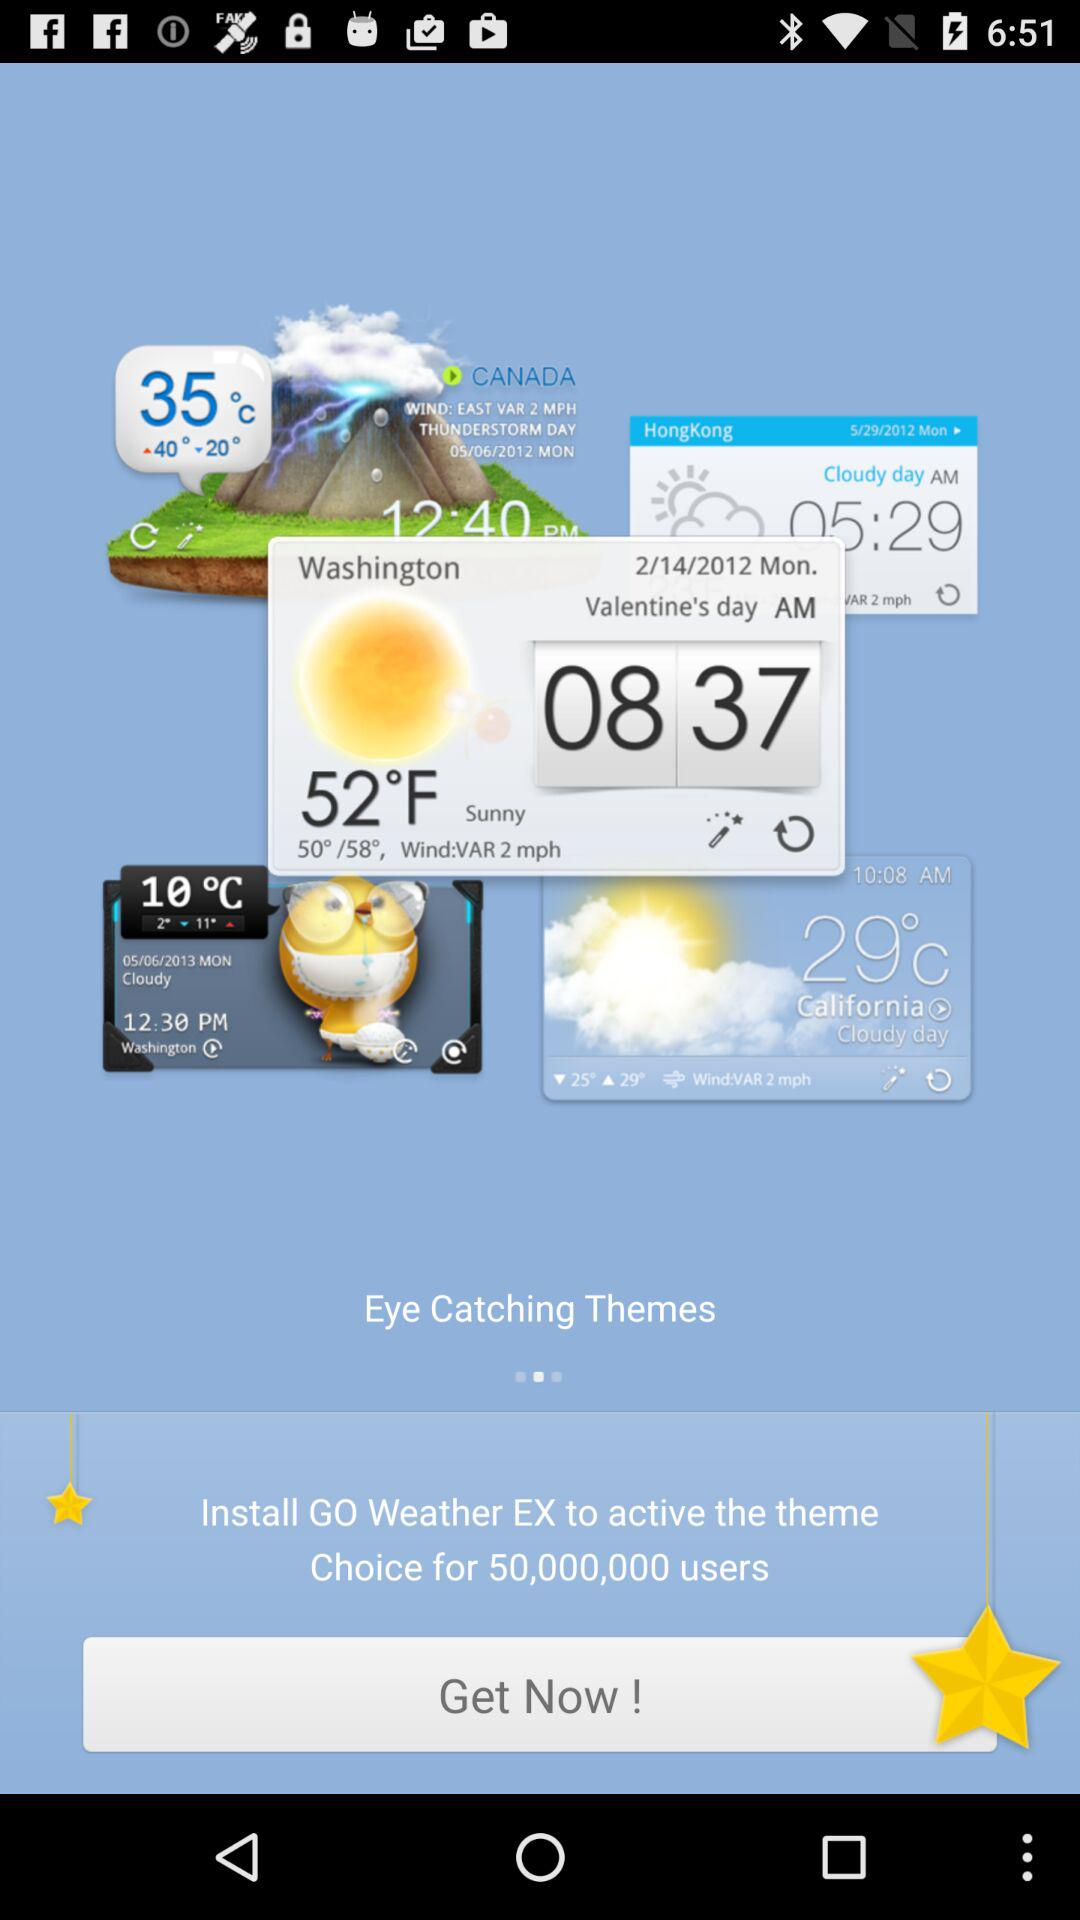For which place is the weather forecast given? The weather forecast is given for Canada, Hong Kong, Washington and California. 